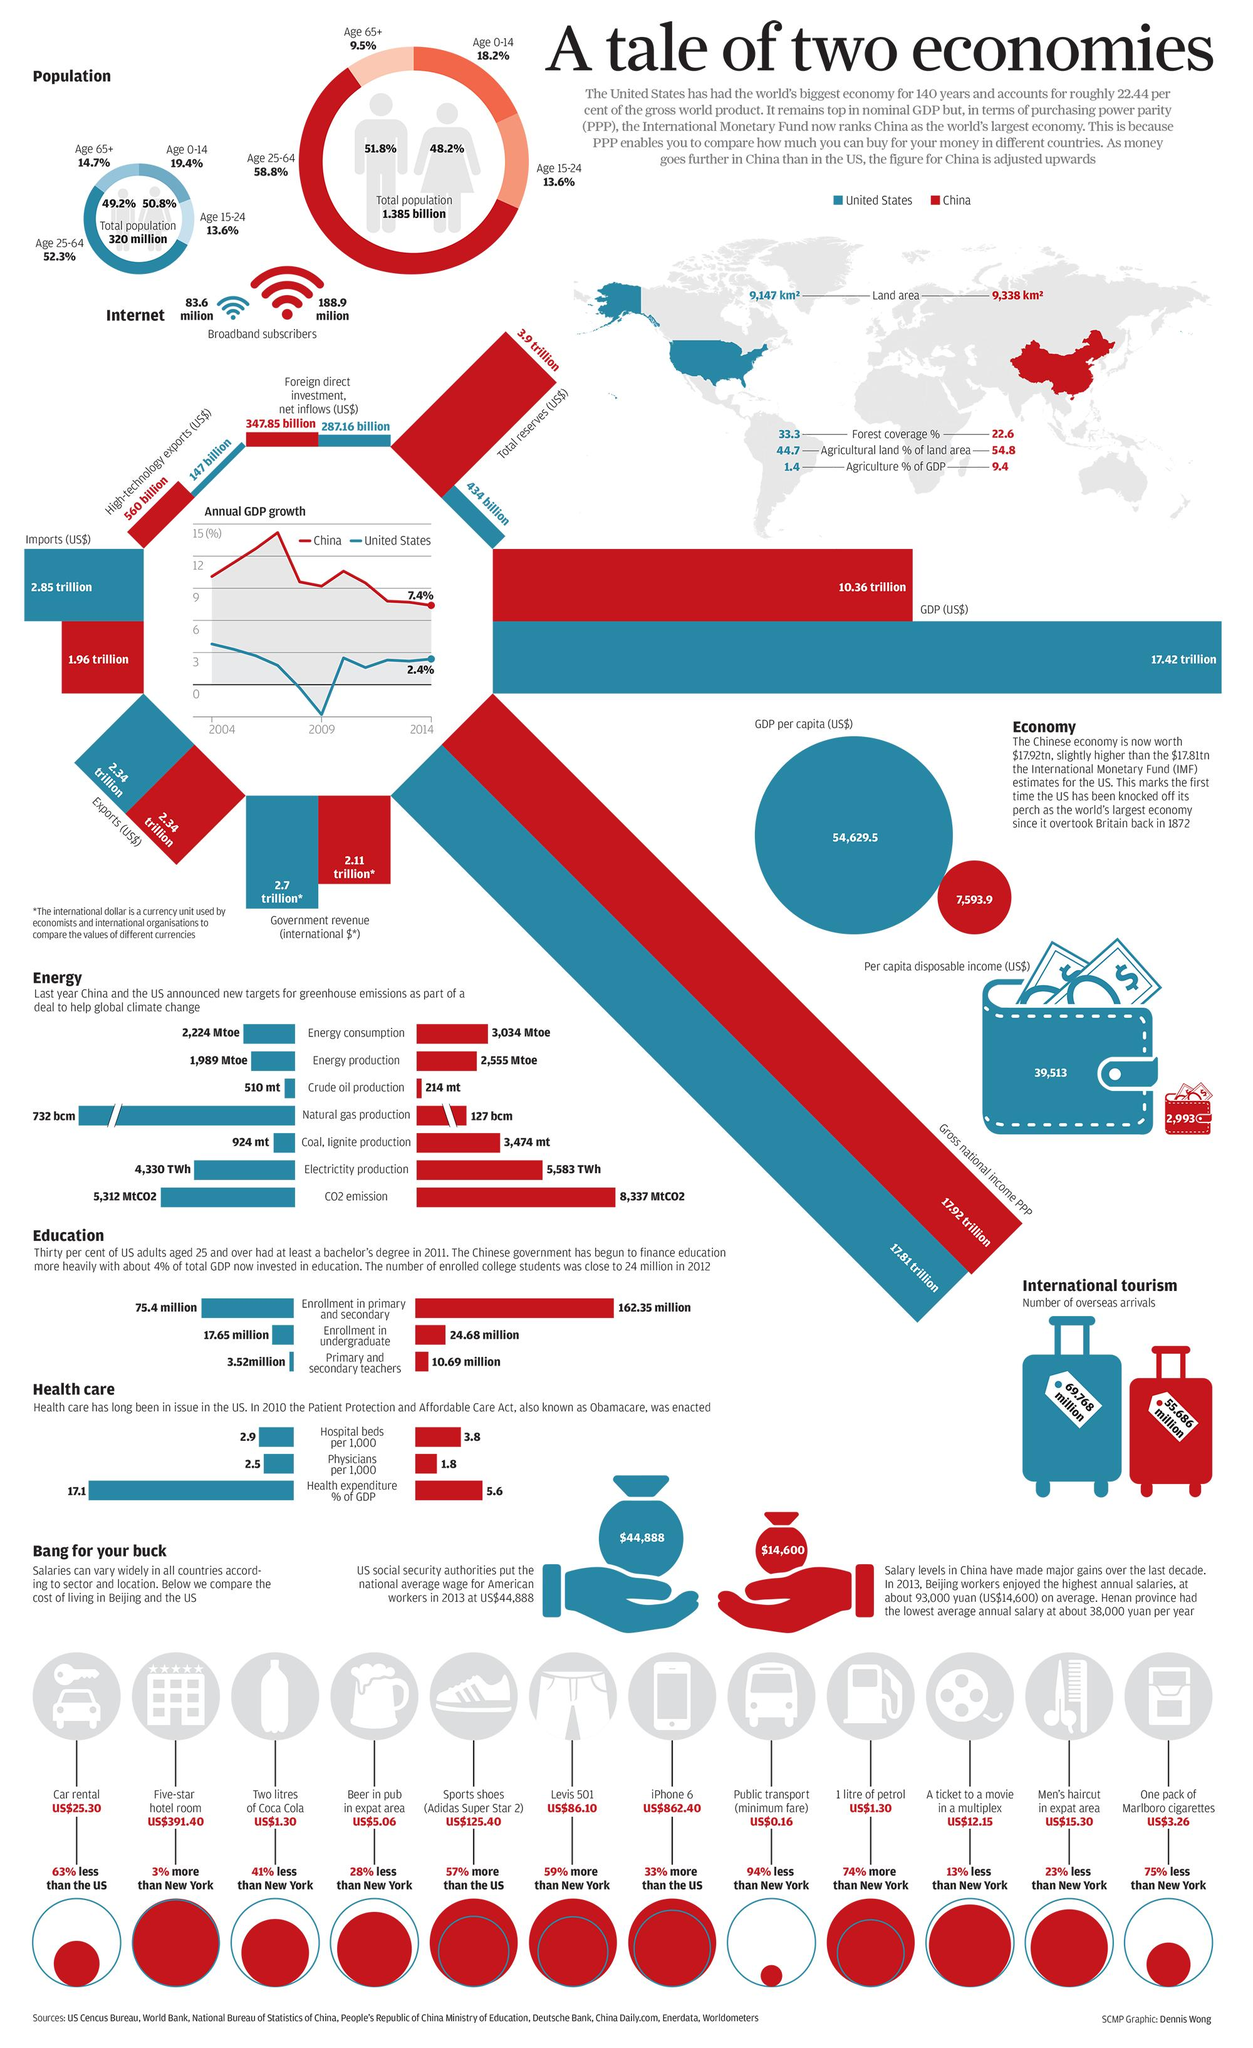Mention a couple of crucial points in this snapshot. The United States has a higher number of overseas arrivals than any other country. In 2014, the annual GDP growth in China was the lowest recorded to date. According to recent data, agriculture accounts for 9.4% of China's Gross Domestic Product (GDP) in 2021. The crude oil production target between China and the US differs by a significant amount. According to a recent survey, 9.5% of senior citizens in China are broadband subscribers. 